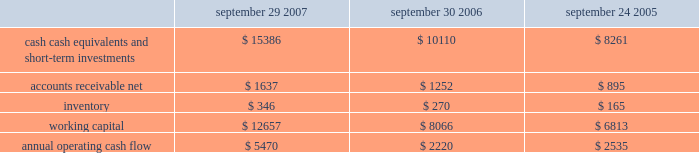No .
159 requires that unrealized gains and losses on items for which the fair value option has been elected be reported in earnings at each reporting date .
Sfas no .
159 is effective for fiscal years beginning after november 15 , 2007 and is required to be adopted by the company beginning in the first quarter of fiscal 2009 .
Although the company will continue to evaluate the application of sfas no .
159 , management does not currently believe adoption will have a material impact on the company 2019s financial condition or operating results .
In september 2006 , the fasb issued sfas no .
157 , fair value measurements , which defines fair value , provides a framework for measuring fair value , and expands the disclosures required for fair value measurements .
Sfas no .
157 applies to other accounting pronouncements that require fair value measurements ; it does not require any new fair value measurements .
Sfas no .
157 is effective for fiscal years beginning after november 15 , 2007 and is required to be adopted by the company beginning in the first quarter of fiscal 2009 .
Although the company will continue to evaluate the application of sfas no .
157 , management does not currently believe adoption will have a material impact on the company 2019s financial condition or operating results .
In june 2006 , the fasb issued fasb interpretation no .
( 2018 2018fin 2019 2019 ) 48 , accounting for uncertainty in income taxes-an interpretation of fasb statement no .
109 .
Fin 48 clarifies the accounting for uncertainty in income taxes by creating a framework for how companies should recognize , measure , present , and disclose in their financial statements uncertain tax positions that they have taken or expect to take in a tax return .
Fin 48 is effective for fiscal years beginning after december 15 , 2006 and is required to be adopted by the company beginning in the first quarter of fiscal 2008 .
Although the company will continue to evaluate the application of fin 48 , management does not currently believe adoption will have a material impact on the company 2019s financial condition or operating results .
Liquidity and capital resources the table presents selected financial information and statistics for each of the last three fiscal years ( dollars in millions ) : september 29 , september 30 , september 24 , 2007 2006 2005 .
As of september 29 , 2007 , the company had $ 15.4 billion in cash , cash equivalents , and short-term investments , an increase of $ 5.3 billion over the same balance at the end of september 30 , 2006 .
The principal components of this net increase were cash generated by operating activities of $ 5.5 billion , proceeds from the issuance of common stock under stock plans of $ 365 million and excess tax benefits from stock-based compensation of $ 377 million .
These increases were partially offset by payments for acquisitions of property , plant , and equipment of $ 735 million and payments for acquisitions of intangible assets of $ 251 million .
The company 2019s short-term investment portfolio is primarily invested in highly rated , liquid investments .
As of september 29 , 2007 and september 30 , 2006 , $ 6.5 billion and $ 4.1 billion , respectively , of the company 2019s cash , cash equivalents , and short-term investments were held by foreign subsidiaries and are generally based in u.s .
Dollar-denominated holdings .
The company believes its existing balances of cash , cash equivalents , and short-term investments will be sufficient to satisfy its working capital needs , capital expenditures , outstanding commitments , and other liquidity requirements associated with its existing operations over the next 12 months. .
What was the highest amount of inventory in the three year period , in millions? 
Computations: table_max(inventory, none)
Answer: 346.0. 